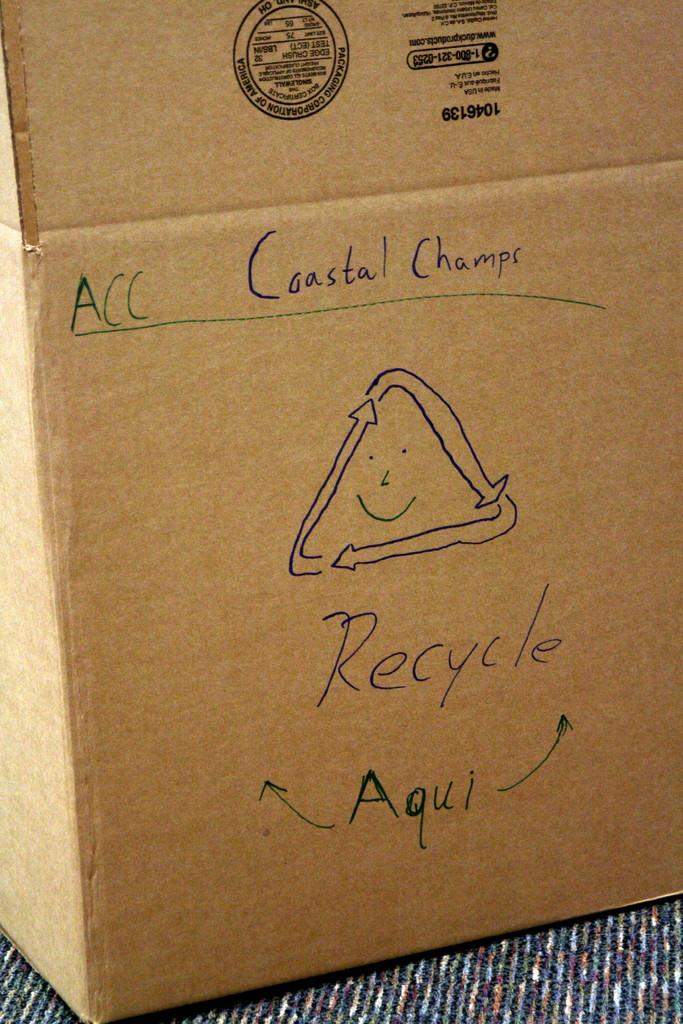<image>
Summarize the visual content of the image. Someone has written Coastal Champs and Recycle on a cardboard box. 